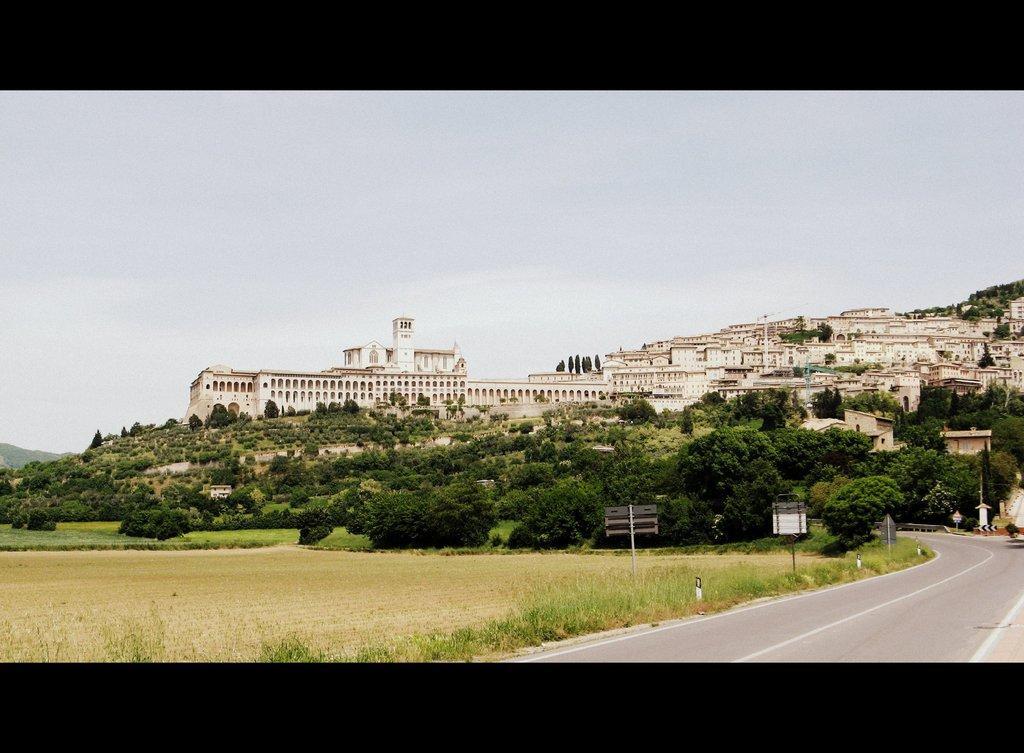How would you summarize this image in a sentence or two? In the picture we can see a road, beside it, we can see a grassy plants and grass surface and in the background, we can see some palace and some buildings and trees and we can also see a sky. 